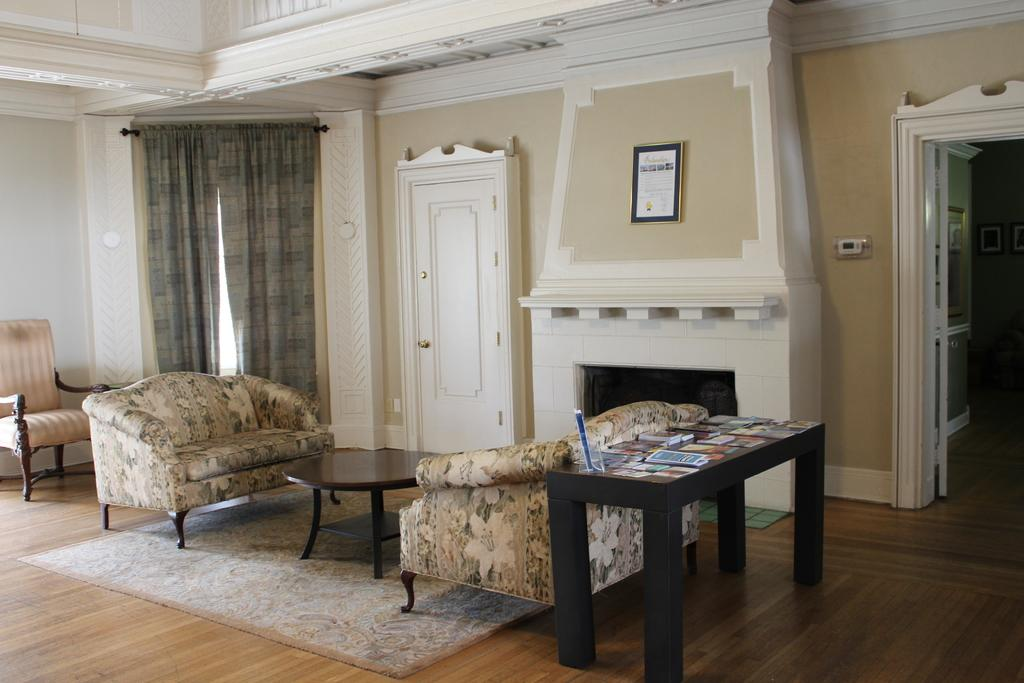What type of space is shown in the image? The image depicts the interior of a room. What furniture is present in the room? There is a sofa, a table, and a chair in the room. What type of window treatment is in the room? There are curtains in the room. What additional item can be seen in the room? There is a shield in the room. Can you tell me how many apples are on the table in the image? There is no apple present on the table in the image. Is there a cook preparing a meal in the room? There is no cook or any indication of food preparation in the image. 